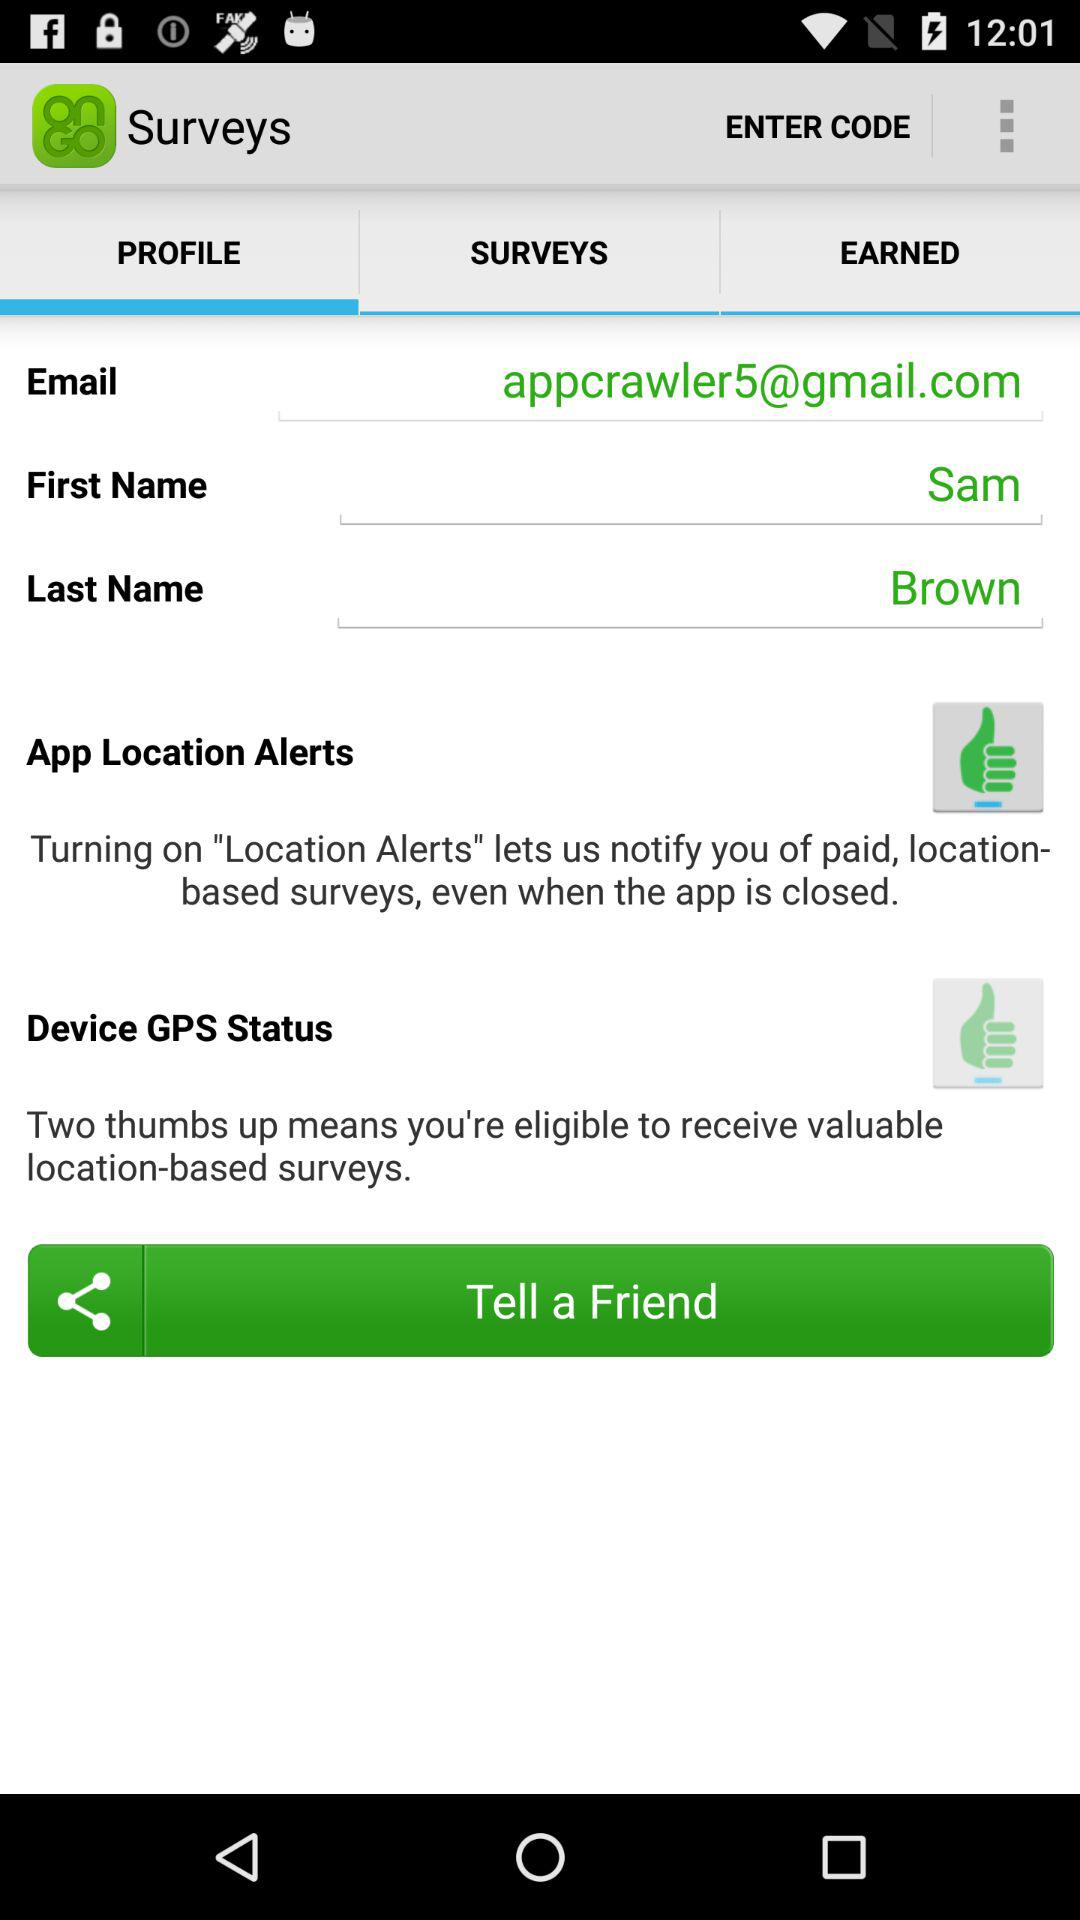Which applications are available for sharing with a friend?
When the provided information is insufficient, respond with <no answer>. <no answer> 